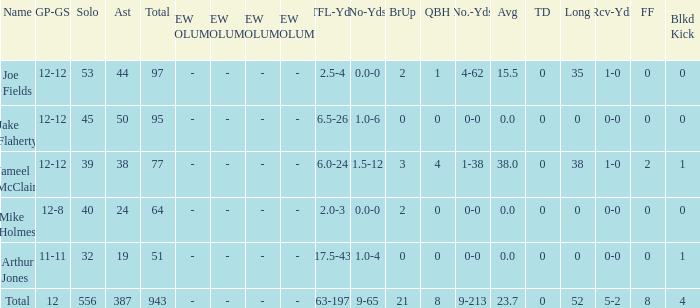Could you help me parse every detail presented in this table? {'header': ['Name', 'GP-GS', 'Solo', 'Ast', 'Total', 'NEW COLUMN 1', 'NEW COLUMN 2', 'NEW COLUMN 3', 'NEW COLUMN 4', 'TFL-Yds', 'No-Yds', 'BrUp', 'QBH', 'No.-Yds', 'Avg', 'TD', 'Long', 'Rcv-Yds', 'FF', 'Blkd Kick'], 'rows': [['Joe Fields', '12-12', '53', '44', '97', '-', '-', '-', '-', '2.5-4', '0.0-0', '2', '1', '4-62', '15.5', '0', '35', '1-0', '0', '0'], ['Jake Flaherty', '12-12', '45', '50', '95', '-', '-', '-', '-', '6.5-26', '1.0-6', '0', '0', '0-0', '0.0', '0', '0', '0-0', '0', '0'], ['Jameel McClain', '12-12', '39', '38', '77', '-', '-', '-', '-', '6.0-24', '1.5-12', '3', '4', '1-38', '38.0', '0', '38', '1-0', '2', '1'], ['Mike Holmes', '12-8', '40', '24', '64', '-', '-', '-', '-', '2.0-3', '0.0-0', '2', '0', '0-0', '0.0', '0', '0', '0-0', '0', '0'], ['Arthur Jones', '11-11', '32', '19', '51', '-', '-', '-', '-', '17.5-43', '1.0-4', '0', '0', '0-0', '0.0', '0', '0', '0-0', '0', '1'], ['Total', '12', '556', '387', '943', '-', '-', '-', '-', '63-197', '9-65', '21', '8', '9-213', '23.7', '0', '52', '5-2', '8', '4']]} How many yards for the player with tfl-yds of 2.5-4? 4-62. 